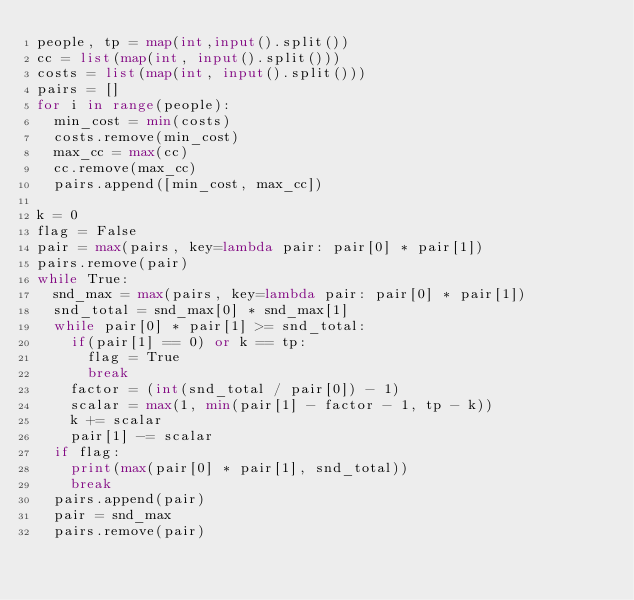Convert code to text. <code><loc_0><loc_0><loc_500><loc_500><_Python_>people, tp = map(int,input().split())
cc = list(map(int, input().split()))
costs = list(map(int, input().split()))
pairs = []
for i in range(people):
	min_cost = min(costs)
	costs.remove(min_cost)
	max_cc = max(cc)
	cc.remove(max_cc)
	pairs.append([min_cost, max_cc])

k = 0
flag = False
pair = max(pairs, key=lambda pair: pair[0] * pair[1])
pairs.remove(pair)
while True:
	snd_max = max(pairs, key=lambda pair: pair[0] * pair[1])
	snd_total = snd_max[0] * snd_max[1]
	while pair[0] * pair[1] >= snd_total:
		if(pair[1] == 0) or k == tp:
			flag = True
			break
		factor = (int(snd_total / pair[0]) - 1)
		scalar = max(1, min(pair[1] - factor - 1, tp - k))
		k += scalar
		pair[1] -= scalar
	if flag:
		print(max(pair[0] * pair[1], snd_total))
		break
	pairs.append(pair)
	pair = snd_max
	pairs.remove(pair)</code> 